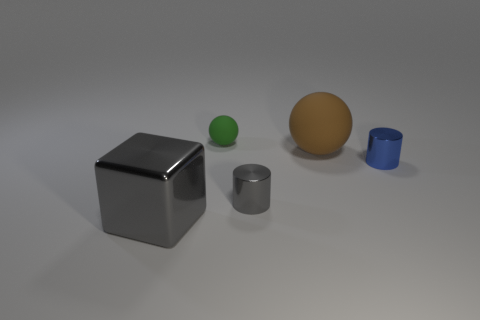Add 3 large cubes. How many objects exist? 8 Subtract all spheres. How many objects are left? 3 Add 4 big rubber objects. How many big rubber objects exist? 5 Subtract 1 green spheres. How many objects are left? 4 Subtract all blue shiny things. Subtract all cubes. How many objects are left? 3 Add 4 small rubber balls. How many small rubber balls are left? 5 